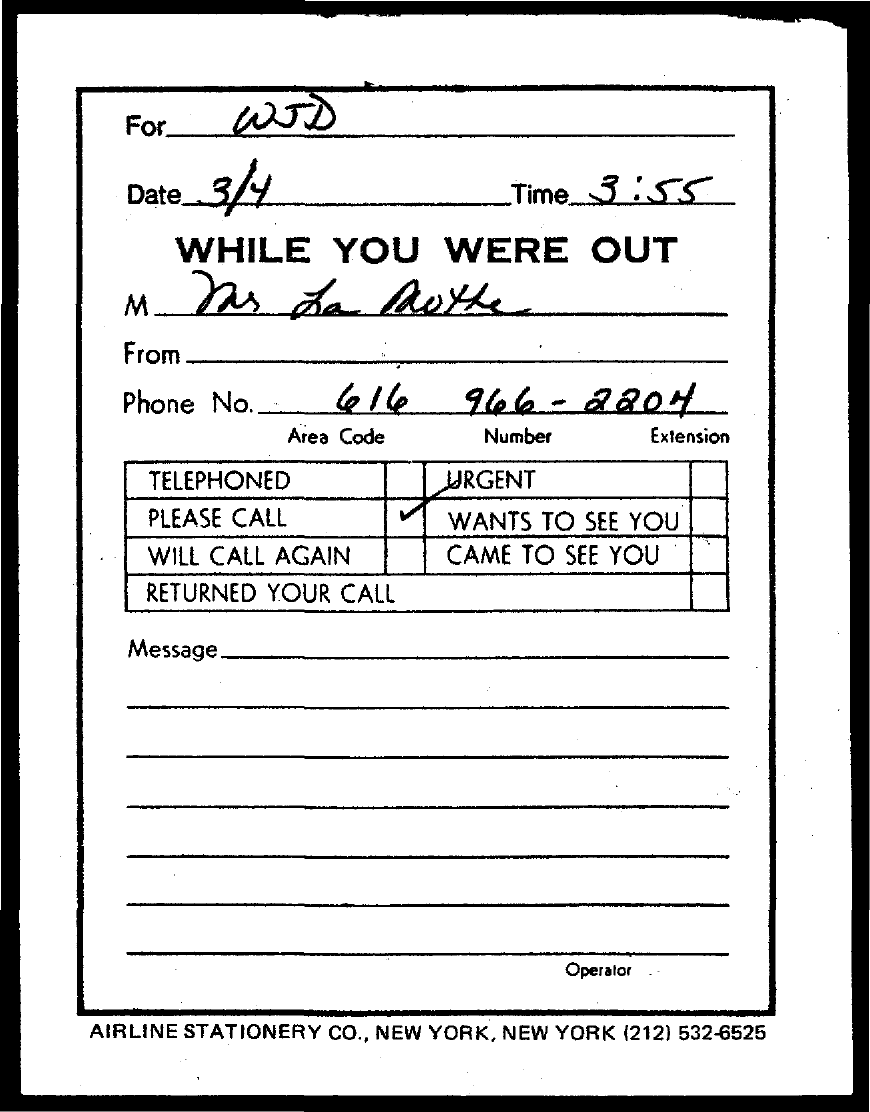What is the date mentioned in this document?
Offer a terse response. 3/4. What is the time mentioned in the slip?
Give a very brief answer. 3 : 55. 